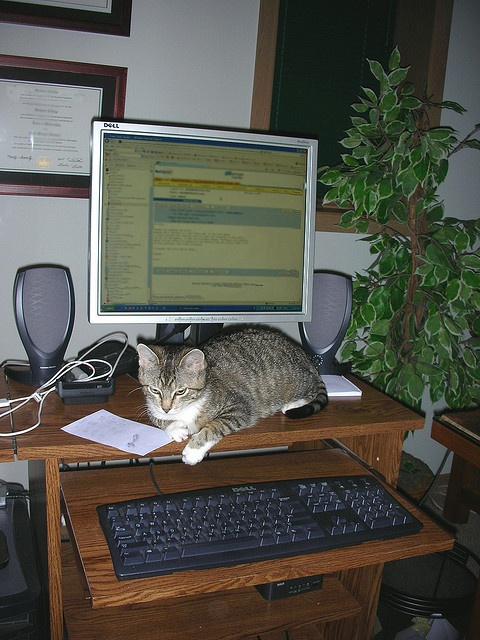Describe the objects in this image and their specific colors. I can see tv in black, gray, olive, white, and darkgreen tones, potted plant in black, darkgreen, and gray tones, keyboard in black, gray, and darkblue tones, and cat in black, gray, darkgray, and lightgray tones in this image. 